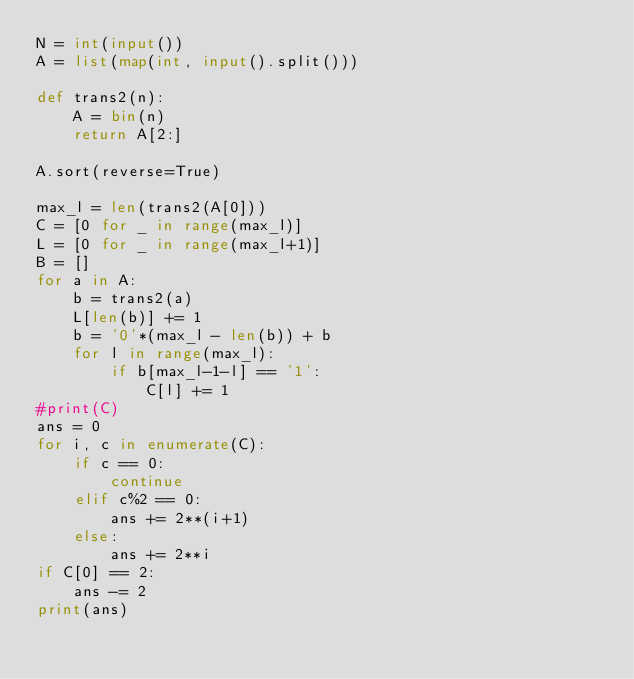<code> <loc_0><loc_0><loc_500><loc_500><_Python_>N = int(input())
A = list(map(int, input().split()))

def trans2(n):
    A = bin(n)
    return A[2:]

A.sort(reverse=True)

max_l = len(trans2(A[0]))
C = [0 for _ in range(max_l)]
L = [0 for _ in range(max_l+1)]
B = []
for a in A:
    b = trans2(a)
    L[len(b)] += 1
    b = '0'*(max_l - len(b)) + b
    for l in range(max_l):
        if b[max_l-1-l] == '1':
            C[l] += 1
#print(C)
ans = 0
for i, c in enumerate(C):
    if c == 0:
        continue
    elif c%2 == 0:
        ans += 2**(i+1)
    else:
        ans += 2**i
if C[0] == 2:
    ans -= 2
print(ans)</code> 